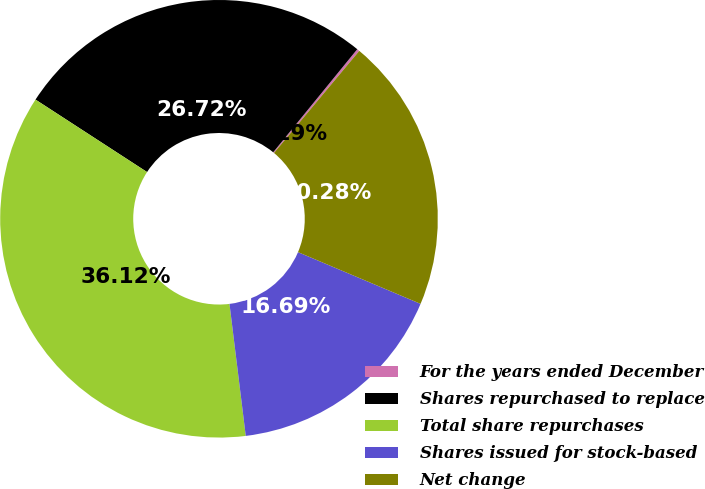Convert chart to OTSL. <chart><loc_0><loc_0><loc_500><loc_500><pie_chart><fcel>For the years ended December<fcel>Shares repurchased to replace<fcel>Total share repurchases<fcel>Shares issued for stock-based<fcel>Net change<nl><fcel>0.19%<fcel>26.72%<fcel>36.12%<fcel>16.69%<fcel>20.28%<nl></chart> 